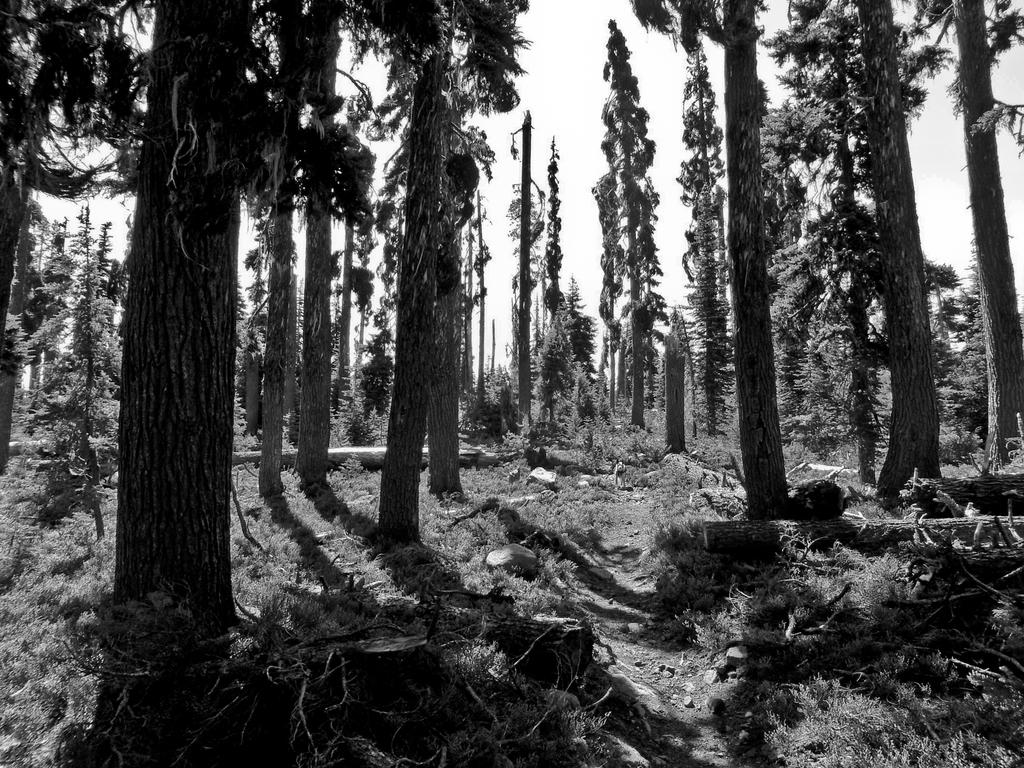What type of vegetation can be seen in the image? There are trees in the image. Can you describe the trees in the image? The provided facts do not include specific details about the trees, so we cannot describe them further. What type of comb is being used to adjust the acoustics in the image? There is no comb or mention of acoustics in the image; it only features trees. 